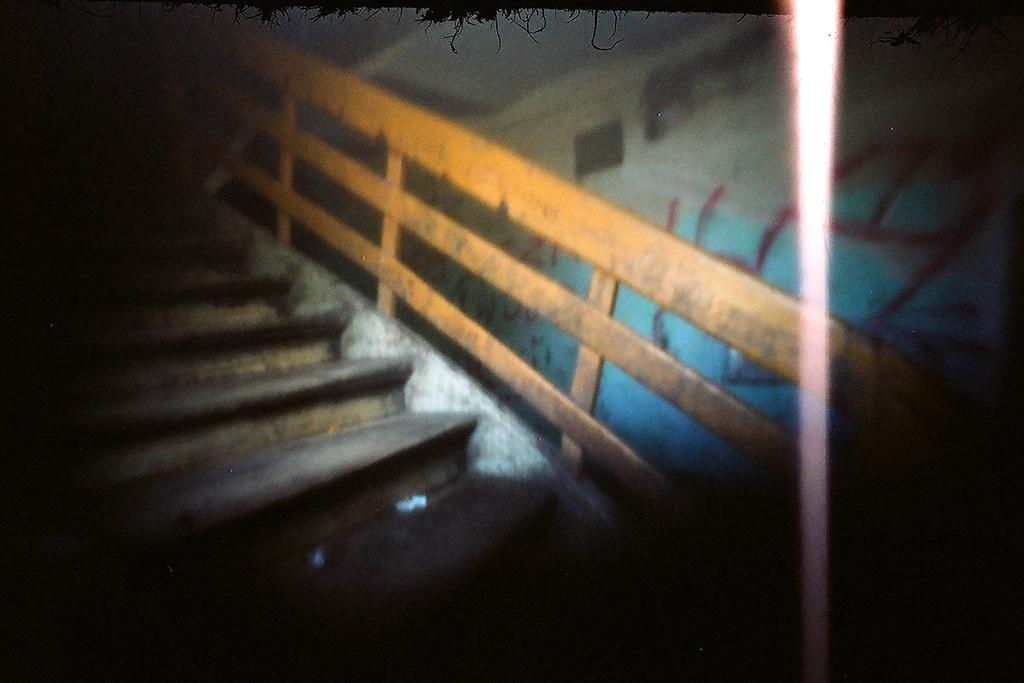What is the main structure in the middle of the image? There is a staircase in the middle of the image. What can be seen on the right side of the image? There is a wall on the right side of the image. What is featured on the wall? There is a painting on the wall. How many brothers are depicted in the painting on the wall? There is no information about any brothers in the image, as the facts only mention the presence of a staircase, a wall, and a painting. 